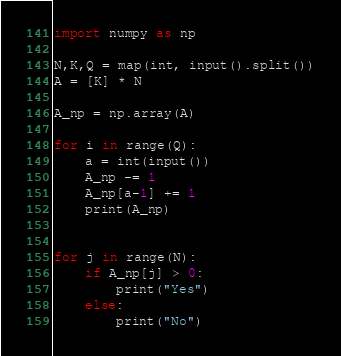<code> <loc_0><loc_0><loc_500><loc_500><_Python_>import numpy as np

N,K,Q = map(int, input().split())
A = [K] * N

A_np = np.array(A)

for i in range(Q):
	a = int(input())
	A_np -= 1
	A_np[a-1] += 1
	print(A_np)


for j in range(N):
	if A_np[j] > 0:
		print("Yes")
	else:
		print("No")</code> 